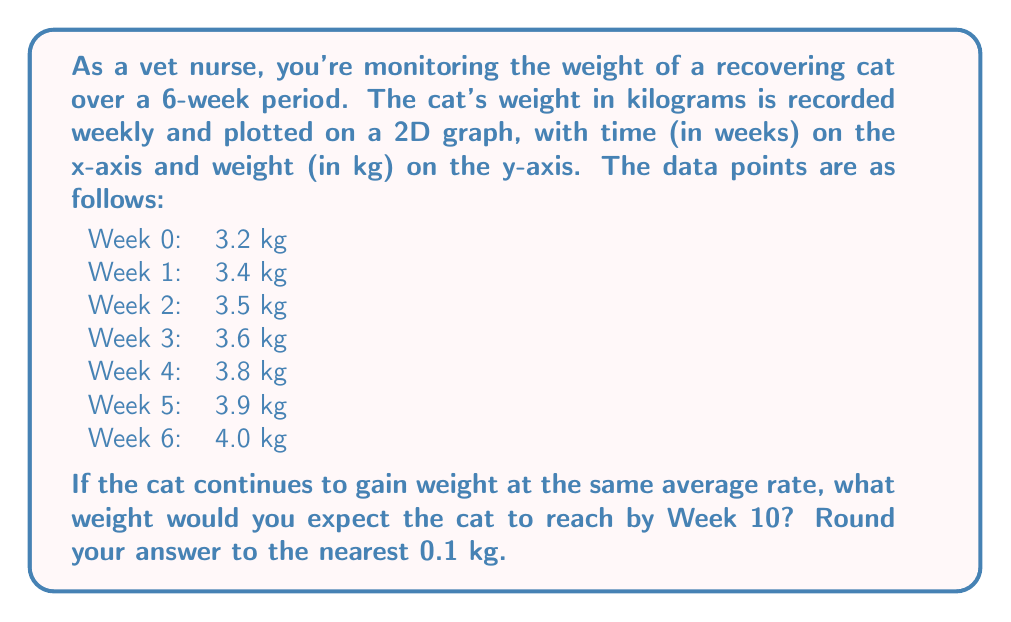Could you help me with this problem? To solve this problem, we need to follow these steps:

1. Plot the given data points on a 2D graph.
2. Calculate the average weight gain per week.
3. Use this rate to predict the weight at Week 10.

Step 1: Plotting the data
We can visualize the data points on a 2D graph:

[asy]
import graph;
size(200,200);
real[] weeks = {0,1,2,3,4,5,6};
real[] weights = {3.2,3.4,3.5,3.6,3.8,3.9,4.0};
for(int i=0; i<7; ++i) {
  dot((weeks[i], weights[i]));
}
xaxis("Weeks",0,6,Arrow);
yaxis("Weight (kg)",3,4.2,Arrow);
label("3.2",(0,3.2),W);
label("4.0",(6,4.0),E);
[/asy]

Step 2: Calculating average weight gain per week
To find the average weight gain per week, we use the formula:

$$ \text{Average weekly gain} = \frac{\text{Total weight gain}}{\text{Number of weeks}} $$

Total weight gain = Final weight - Initial weight
$$ 4.0 \text{ kg} - 3.2 \text{ kg} = 0.8 \text{ kg} $$

Number of weeks = 6

$$ \text{Average weekly gain} = \frac{0.8 \text{ kg}}{6 \text{ weeks}} = 0.1333... \text{ kg/week} $$

Step 3: Predicting weight at Week 10
To predict the weight at Week 10, we need to:
a) Calculate how many weeks beyond our data we're predicting (10 - 6 = 4 weeks)
b) Multiply this by our average weekly gain
c) Add this to our last recorded weight

$$ \text{Predicted weight gain} = 4 \text{ weeks} \times 0.1333... \text{ kg/week} = 0.5333... \text{ kg} $$
$$ \text{Predicted weight at Week 10} = 4.0 \text{ kg} + 0.5333... \text{ kg} = 4.5333... \text{ kg} $$

Rounding to the nearest 0.1 kg, we get 4.5 kg.
Answer: 4.5 kg 